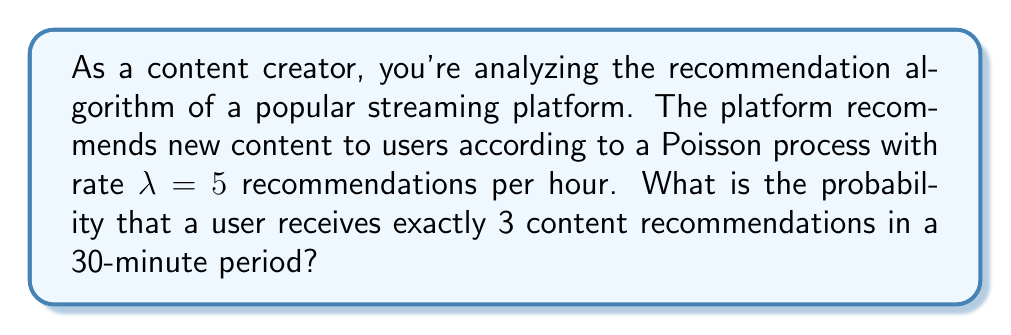Can you answer this question? Let's approach this step-by-step:

1) The Poisson process has a rate $\lambda = 5$ recommendations per hour.

2) We need to find the rate for a 30-minute period. Since 30 minutes is half an hour:
   $\lambda_{30min} = 5 \cdot \frac{1}{2} = 2.5$ recommendations per 30 minutes

3) The probability of exactly $k$ events occurring in a Poisson process over a time interval $t$ is given by the Poisson probability mass function:

   $$P(X = k) = \frac{e^{-\lambda t}(\lambda t)^k}{k!}$$

4) In this case, $k = 3$, and $\lambda t = 2.5$. Let's substitute these values:

   $$P(X = 3) = \frac{e^{-2.5}(2.5)^3}{3!}$$

5) Now, let's calculate:
   
   $$P(X = 3) = \frac{e^{-2.5} \cdot 15.625}{6}$$

6) Using a calculator:

   $$P(X = 3) \approx 0.1566$$

Therefore, the probability of receiving exactly 3 content recommendations in a 30-minute period is approximately 0.1566 or 15.66%.
Answer: 0.1566 